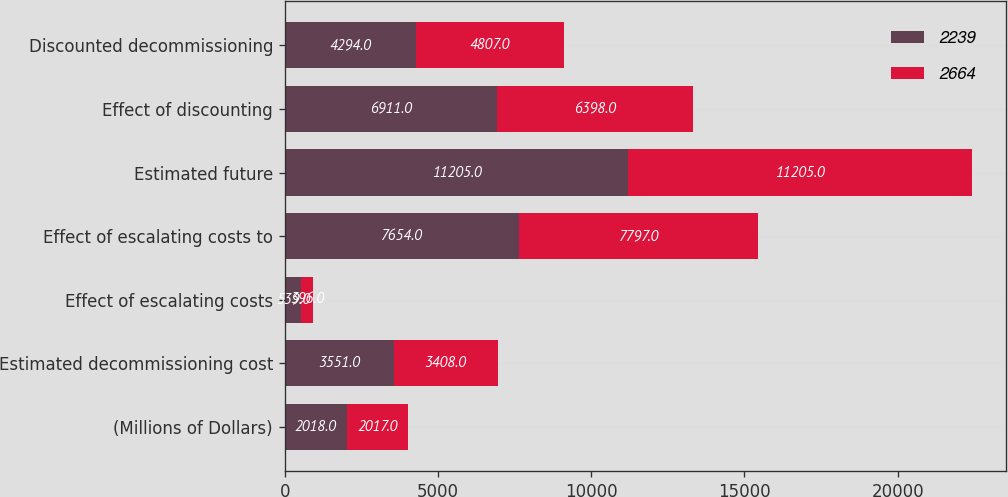Convert chart to OTSL. <chart><loc_0><loc_0><loc_500><loc_500><stacked_bar_chart><ecel><fcel>(Millions of Dollars)<fcel>Estimated decommissioning cost<fcel>Effect of escalating costs<fcel>Effect of escalating costs to<fcel>Estimated future<fcel>Effect of discounting<fcel>Discounted decommissioning<nl><fcel>2239<fcel>2018<fcel>3551<fcel>539<fcel>7654<fcel>11205<fcel>6911<fcel>4294<nl><fcel>2664<fcel>2017<fcel>3408<fcel>396<fcel>7797<fcel>11205<fcel>6398<fcel>4807<nl></chart> 